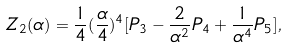Convert formula to latex. <formula><loc_0><loc_0><loc_500><loc_500>Z _ { 2 } ( \alpha ) = \frac { 1 } { 4 } ( \frac { \alpha } { 4 } ) ^ { 4 } [ P _ { 3 } - \frac { 2 } { \alpha ^ { 2 } } P _ { 4 } + \frac { 1 } { \alpha ^ { 4 } } P _ { 5 } ] ,</formula> 